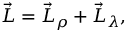Convert formula to latex. <formula><loc_0><loc_0><loc_500><loc_500>{ \vec { L } } = { \vec { L } } _ { \rho } + { \vec { L } } _ { \lambda } ,</formula> 